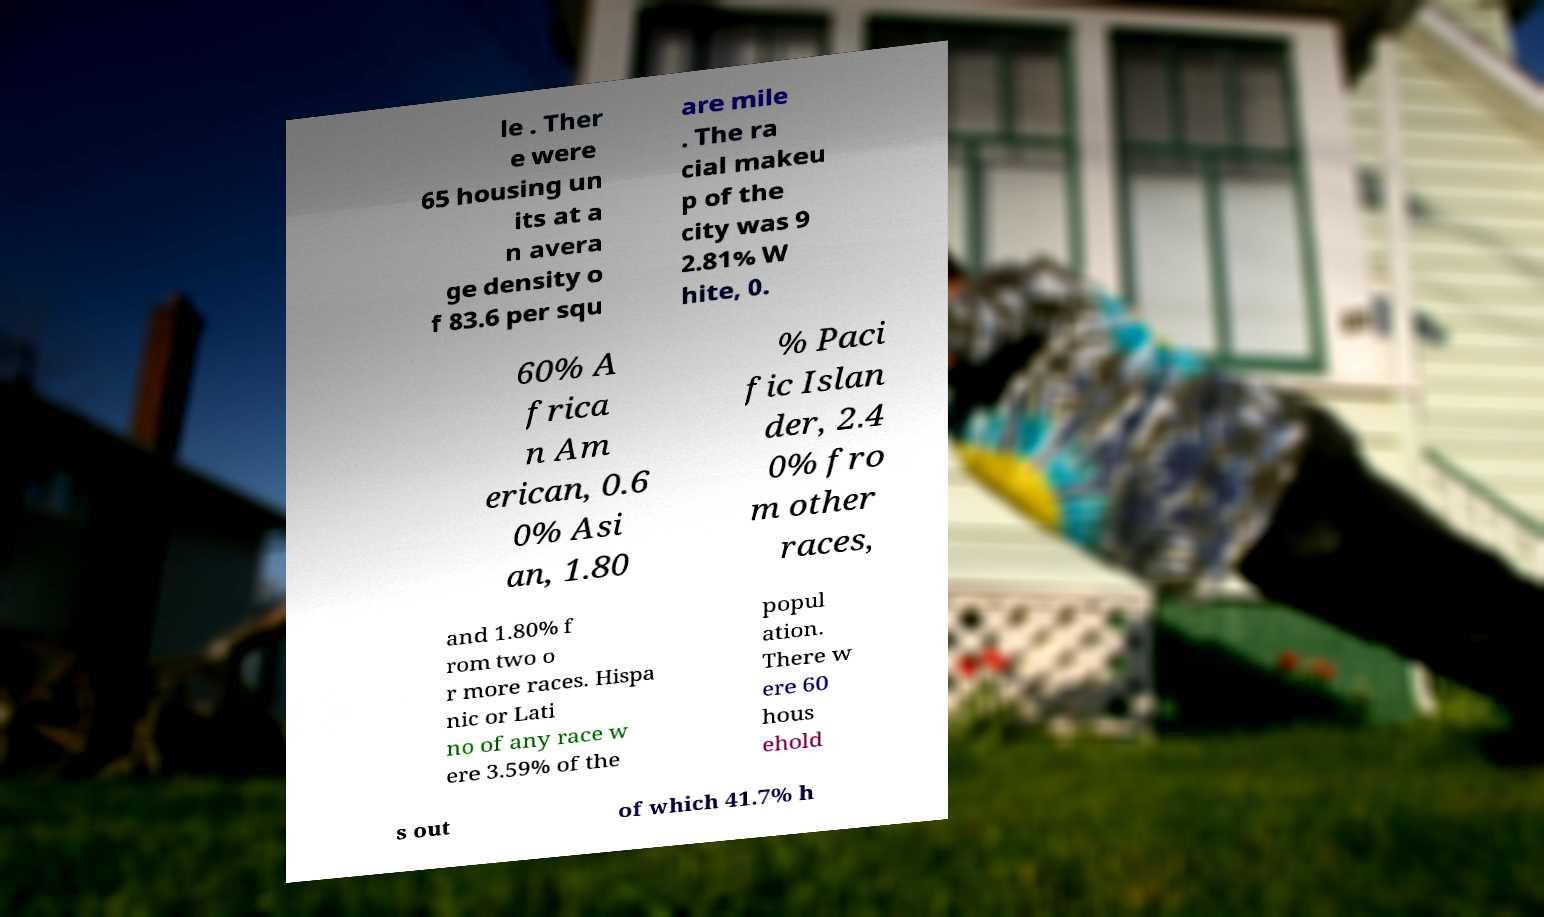Could you extract and type out the text from this image? le . Ther e were 65 housing un its at a n avera ge density o f 83.6 per squ are mile . The ra cial makeu p of the city was 9 2.81% W hite, 0. 60% A frica n Am erican, 0.6 0% Asi an, 1.80 % Paci fic Islan der, 2.4 0% fro m other races, and 1.80% f rom two o r more races. Hispa nic or Lati no of any race w ere 3.59% of the popul ation. There w ere 60 hous ehold s out of which 41.7% h 